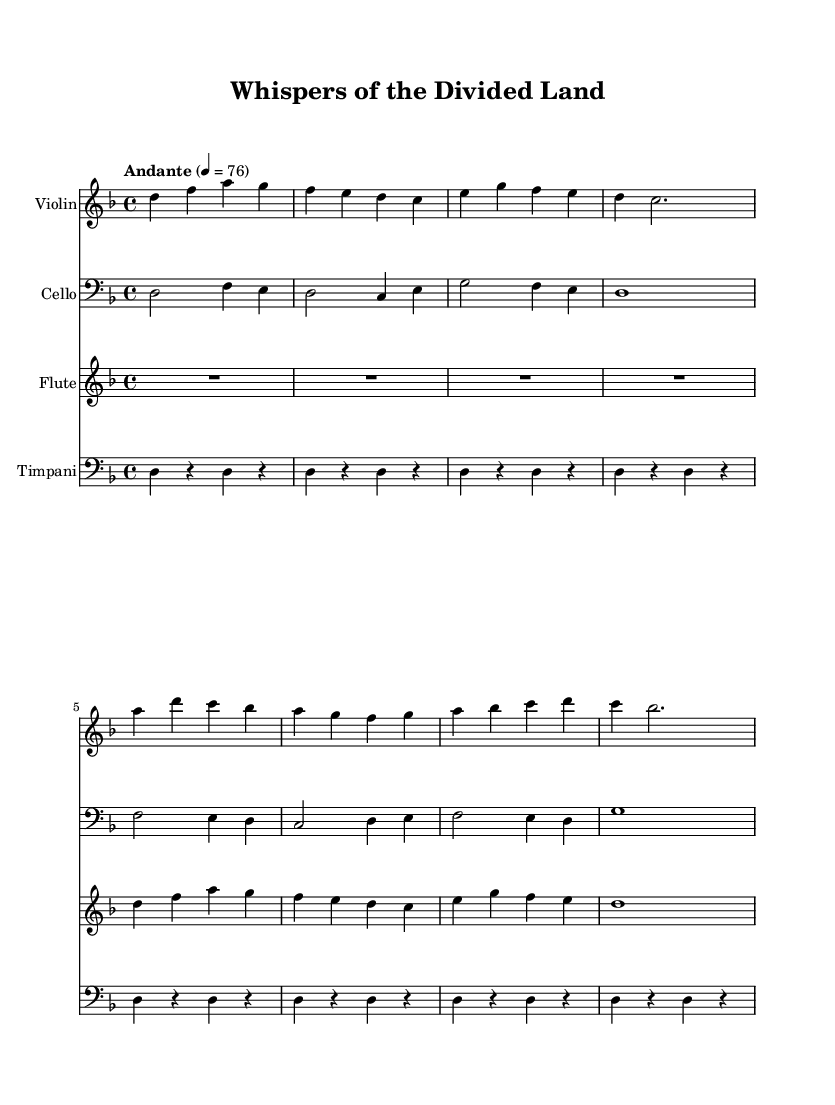What is the key signature of this music? The key signature is two flats, indicating that the piece is in D minor. This is identified by the presence of the flat signs on the B and E notes.
Answer: D minor What is the time signature of this music? The time signature is 4/4, as indicated at the beginning of the score. This means there are four beats per measure, and the quarter note gets one beat.
Answer: 4/4 What is the tempo marking given for the piece? The tempo marking is "Andante," which describes the speed of the music, suggesting a moderately slow pace. The BPM (beats per minute) indicated is 76.
Answer: Andante Which instrument plays the initial silence? The flute is indicated to start with a rest for the first measure, denoted by "R1*4." This shows that the flute does not play for four beats at the beginning.
Answer: Flute What is the highest note played in the violin part? The highest note in the violin part is an A, which is found in the third measure as the octave higher than middle C. This can be determined by checking the pitch placements on the staff.
Answer: A How many measures are there in the cello part? The cello part consists of eight measures, as denoted by the groupings of notes and rests clearly separated in the score. Each written set of notes or rests represents one measure.
Answer: Eight measures What does the presence of both traditional and Western instruments suggest about the music? The inclusion of traditional Korean instruments, such as the usage of instrumentation reminiscent of Korean styles alongside Western orchestral elements, suggests a fusion genre that aims to blend cultural musical expressions. This adds richness and diversity to the overall sound of the composition.
Answer: Fusion genre 